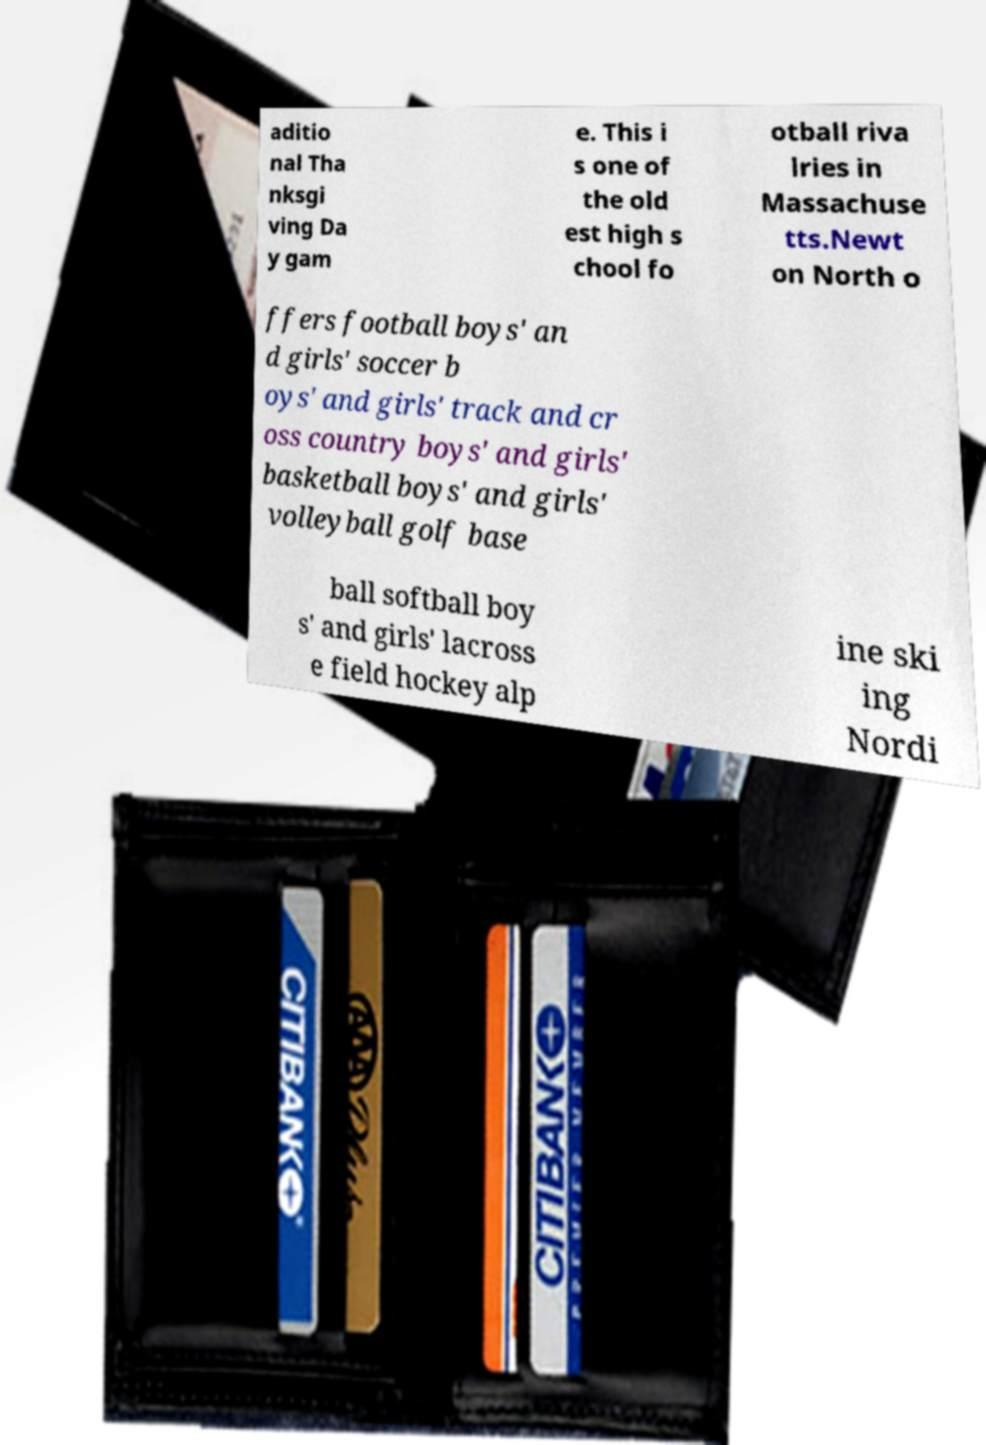Could you assist in decoding the text presented in this image and type it out clearly? aditio nal Tha nksgi ving Da y gam e. This i s one of the old est high s chool fo otball riva lries in Massachuse tts.Newt on North o ffers football boys' an d girls' soccer b oys' and girls' track and cr oss country boys' and girls' basketball boys' and girls' volleyball golf base ball softball boy s' and girls' lacross e field hockey alp ine ski ing Nordi 